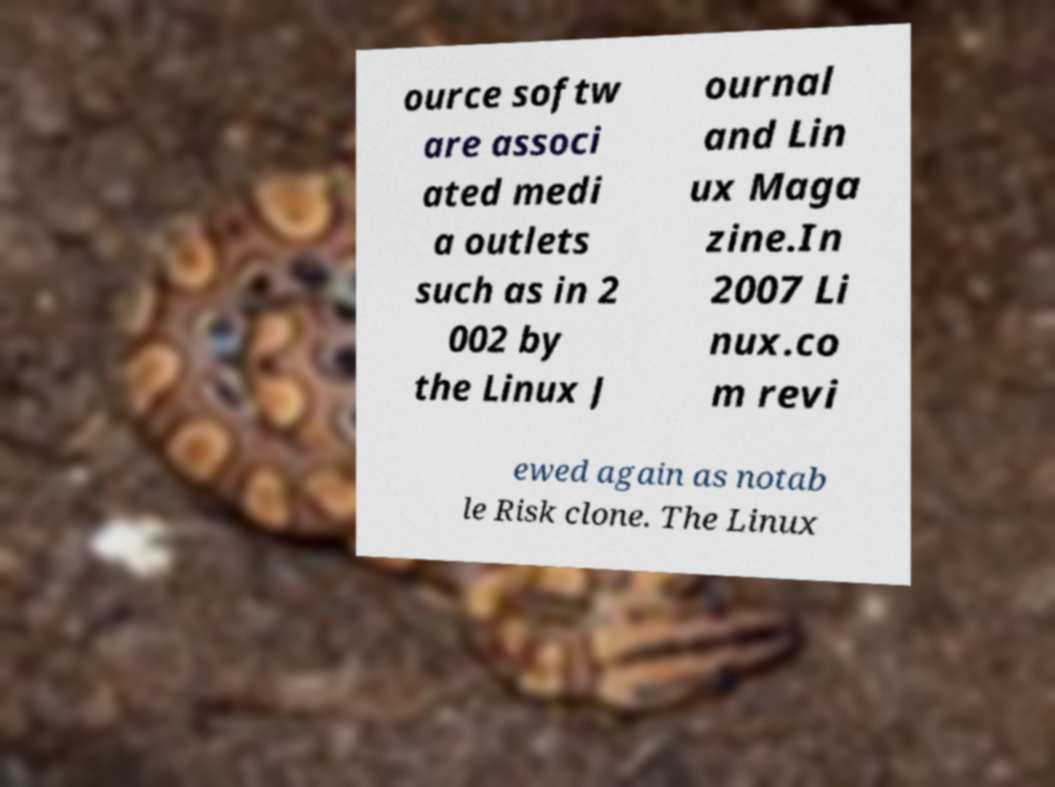There's text embedded in this image that I need extracted. Can you transcribe it verbatim? ource softw are associ ated medi a outlets such as in 2 002 by the Linux J ournal and Lin ux Maga zine.In 2007 Li nux.co m revi ewed again as notab le Risk clone. The Linux 